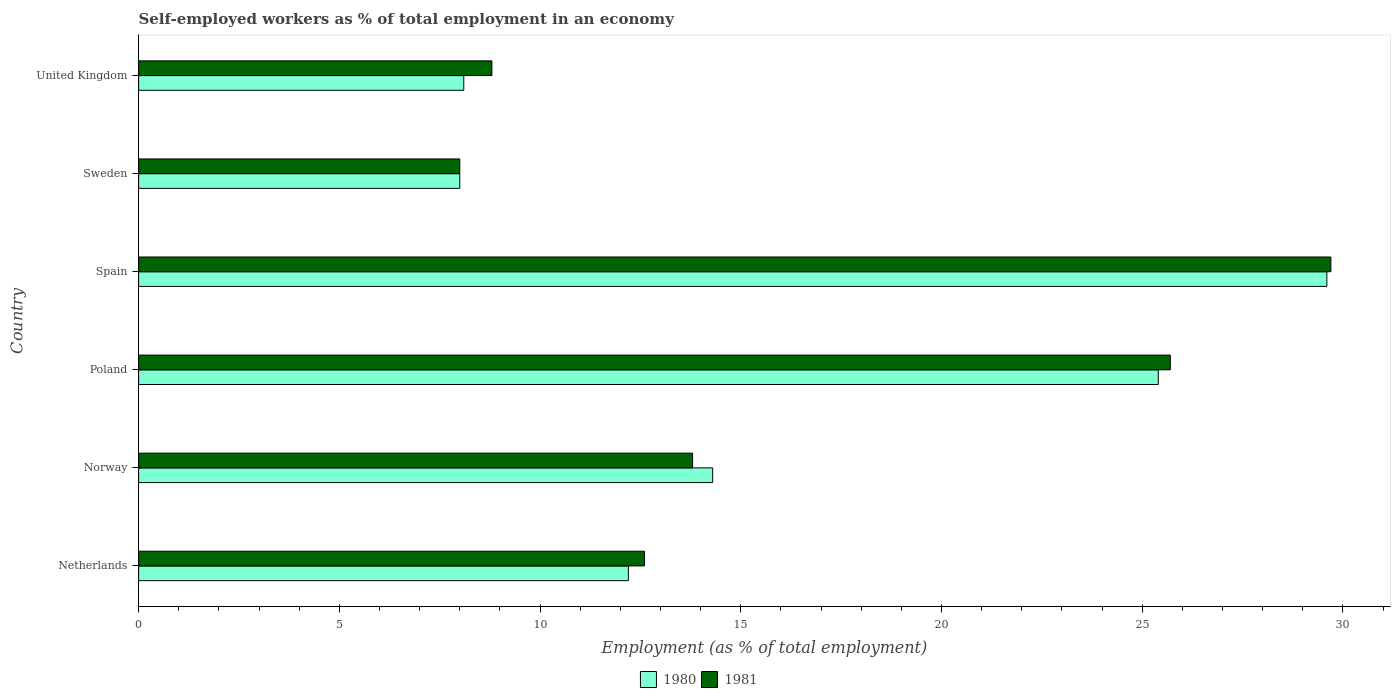How many groups of bars are there?
Your answer should be very brief. 6. What is the label of the 4th group of bars from the top?
Your response must be concise. Poland. What is the percentage of self-employed workers in 1981 in Spain?
Your answer should be compact. 29.7. Across all countries, what is the maximum percentage of self-employed workers in 1980?
Your answer should be compact. 29.6. In which country was the percentage of self-employed workers in 1980 maximum?
Provide a succinct answer. Spain. In which country was the percentage of self-employed workers in 1980 minimum?
Make the answer very short. Sweden. What is the total percentage of self-employed workers in 1981 in the graph?
Offer a very short reply. 98.6. What is the difference between the percentage of self-employed workers in 1981 in Sweden and that in United Kingdom?
Offer a terse response. -0.8. What is the difference between the percentage of self-employed workers in 1980 in Spain and the percentage of self-employed workers in 1981 in United Kingdom?
Your answer should be compact. 20.8. What is the average percentage of self-employed workers in 1980 per country?
Ensure brevity in your answer.  16.27. What is the difference between the percentage of self-employed workers in 1981 and percentage of self-employed workers in 1980 in Norway?
Your answer should be compact. -0.5. In how many countries, is the percentage of self-employed workers in 1981 greater than 12 %?
Your response must be concise. 4. What is the ratio of the percentage of self-employed workers in 1980 in Norway to that in United Kingdom?
Give a very brief answer. 1.77. Is the percentage of self-employed workers in 1981 in Poland less than that in Sweden?
Your answer should be very brief. No. Is the difference between the percentage of self-employed workers in 1981 in Sweden and United Kingdom greater than the difference between the percentage of self-employed workers in 1980 in Sweden and United Kingdom?
Your answer should be very brief. No. What is the difference between the highest and the second highest percentage of self-employed workers in 1981?
Give a very brief answer. 4. What is the difference between the highest and the lowest percentage of self-employed workers in 1981?
Keep it short and to the point. 21.7. In how many countries, is the percentage of self-employed workers in 1980 greater than the average percentage of self-employed workers in 1980 taken over all countries?
Ensure brevity in your answer.  2. Is the sum of the percentage of self-employed workers in 1980 in Netherlands and Spain greater than the maximum percentage of self-employed workers in 1981 across all countries?
Keep it short and to the point. Yes. What does the 2nd bar from the bottom in Sweden represents?
Offer a terse response. 1981. How many countries are there in the graph?
Your answer should be compact. 6. What is the difference between two consecutive major ticks on the X-axis?
Your answer should be very brief. 5. Does the graph contain any zero values?
Give a very brief answer. No. Does the graph contain grids?
Offer a terse response. No. Where does the legend appear in the graph?
Provide a short and direct response. Bottom center. How many legend labels are there?
Offer a very short reply. 2. What is the title of the graph?
Offer a terse response. Self-employed workers as % of total employment in an economy. What is the label or title of the X-axis?
Make the answer very short. Employment (as % of total employment). What is the label or title of the Y-axis?
Ensure brevity in your answer.  Country. What is the Employment (as % of total employment) of 1980 in Netherlands?
Offer a terse response. 12.2. What is the Employment (as % of total employment) of 1981 in Netherlands?
Your response must be concise. 12.6. What is the Employment (as % of total employment) in 1980 in Norway?
Give a very brief answer. 14.3. What is the Employment (as % of total employment) in 1981 in Norway?
Give a very brief answer. 13.8. What is the Employment (as % of total employment) of 1980 in Poland?
Your answer should be very brief. 25.4. What is the Employment (as % of total employment) of 1981 in Poland?
Provide a succinct answer. 25.7. What is the Employment (as % of total employment) of 1980 in Spain?
Ensure brevity in your answer.  29.6. What is the Employment (as % of total employment) in 1981 in Spain?
Provide a succinct answer. 29.7. What is the Employment (as % of total employment) of 1980 in Sweden?
Provide a succinct answer. 8. What is the Employment (as % of total employment) in 1981 in Sweden?
Your response must be concise. 8. What is the Employment (as % of total employment) in 1980 in United Kingdom?
Keep it short and to the point. 8.1. What is the Employment (as % of total employment) of 1981 in United Kingdom?
Your answer should be compact. 8.8. Across all countries, what is the maximum Employment (as % of total employment) of 1980?
Make the answer very short. 29.6. Across all countries, what is the maximum Employment (as % of total employment) of 1981?
Provide a succinct answer. 29.7. Across all countries, what is the minimum Employment (as % of total employment) in 1980?
Your answer should be very brief. 8. What is the total Employment (as % of total employment) of 1980 in the graph?
Make the answer very short. 97.6. What is the total Employment (as % of total employment) of 1981 in the graph?
Offer a terse response. 98.6. What is the difference between the Employment (as % of total employment) of 1980 in Netherlands and that in Norway?
Offer a very short reply. -2.1. What is the difference between the Employment (as % of total employment) in 1981 in Netherlands and that in Norway?
Offer a very short reply. -1.2. What is the difference between the Employment (as % of total employment) of 1981 in Netherlands and that in Poland?
Offer a very short reply. -13.1. What is the difference between the Employment (as % of total employment) of 1980 in Netherlands and that in Spain?
Keep it short and to the point. -17.4. What is the difference between the Employment (as % of total employment) of 1981 in Netherlands and that in Spain?
Give a very brief answer. -17.1. What is the difference between the Employment (as % of total employment) in 1981 in Netherlands and that in Sweden?
Your response must be concise. 4.6. What is the difference between the Employment (as % of total employment) in 1980 in Netherlands and that in United Kingdom?
Provide a succinct answer. 4.1. What is the difference between the Employment (as % of total employment) of 1981 in Norway and that in Poland?
Make the answer very short. -11.9. What is the difference between the Employment (as % of total employment) of 1980 in Norway and that in Spain?
Make the answer very short. -15.3. What is the difference between the Employment (as % of total employment) of 1981 in Norway and that in Spain?
Provide a short and direct response. -15.9. What is the difference between the Employment (as % of total employment) in 1980 in Norway and that in Sweden?
Make the answer very short. 6.3. What is the difference between the Employment (as % of total employment) of 1981 in Norway and that in Sweden?
Give a very brief answer. 5.8. What is the difference between the Employment (as % of total employment) of 1980 in Poland and that in Sweden?
Ensure brevity in your answer.  17.4. What is the difference between the Employment (as % of total employment) of 1981 in Poland and that in Sweden?
Ensure brevity in your answer.  17.7. What is the difference between the Employment (as % of total employment) of 1980 in Poland and that in United Kingdom?
Offer a terse response. 17.3. What is the difference between the Employment (as % of total employment) of 1980 in Spain and that in Sweden?
Your answer should be very brief. 21.6. What is the difference between the Employment (as % of total employment) of 1981 in Spain and that in Sweden?
Give a very brief answer. 21.7. What is the difference between the Employment (as % of total employment) in 1980 in Spain and that in United Kingdom?
Provide a short and direct response. 21.5. What is the difference between the Employment (as % of total employment) of 1981 in Spain and that in United Kingdom?
Your answer should be very brief. 20.9. What is the difference between the Employment (as % of total employment) of 1980 in Sweden and that in United Kingdom?
Offer a very short reply. -0.1. What is the difference between the Employment (as % of total employment) in 1981 in Sweden and that in United Kingdom?
Keep it short and to the point. -0.8. What is the difference between the Employment (as % of total employment) in 1980 in Netherlands and the Employment (as % of total employment) in 1981 in Norway?
Provide a succinct answer. -1.6. What is the difference between the Employment (as % of total employment) of 1980 in Netherlands and the Employment (as % of total employment) of 1981 in Spain?
Your answer should be very brief. -17.5. What is the difference between the Employment (as % of total employment) in 1980 in Norway and the Employment (as % of total employment) in 1981 in Poland?
Provide a short and direct response. -11.4. What is the difference between the Employment (as % of total employment) in 1980 in Norway and the Employment (as % of total employment) in 1981 in Spain?
Offer a terse response. -15.4. What is the difference between the Employment (as % of total employment) of 1980 in Norway and the Employment (as % of total employment) of 1981 in United Kingdom?
Your answer should be very brief. 5.5. What is the difference between the Employment (as % of total employment) of 1980 in Poland and the Employment (as % of total employment) of 1981 in Spain?
Ensure brevity in your answer.  -4.3. What is the difference between the Employment (as % of total employment) in 1980 in Spain and the Employment (as % of total employment) in 1981 in Sweden?
Give a very brief answer. 21.6. What is the difference between the Employment (as % of total employment) in 1980 in Spain and the Employment (as % of total employment) in 1981 in United Kingdom?
Your answer should be compact. 20.8. What is the average Employment (as % of total employment) in 1980 per country?
Offer a terse response. 16.27. What is the average Employment (as % of total employment) of 1981 per country?
Your response must be concise. 16.43. What is the difference between the Employment (as % of total employment) in 1980 and Employment (as % of total employment) in 1981 in Netherlands?
Keep it short and to the point. -0.4. What is the difference between the Employment (as % of total employment) of 1980 and Employment (as % of total employment) of 1981 in Spain?
Your answer should be compact. -0.1. What is the difference between the Employment (as % of total employment) in 1980 and Employment (as % of total employment) in 1981 in Sweden?
Give a very brief answer. 0. What is the ratio of the Employment (as % of total employment) in 1980 in Netherlands to that in Norway?
Keep it short and to the point. 0.85. What is the ratio of the Employment (as % of total employment) in 1981 in Netherlands to that in Norway?
Make the answer very short. 0.91. What is the ratio of the Employment (as % of total employment) in 1980 in Netherlands to that in Poland?
Provide a succinct answer. 0.48. What is the ratio of the Employment (as % of total employment) of 1981 in Netherlands to that in Poland?
Offer a very short reply. 0.49. What is the ratio of the Employment (as % of total employment) in 1980 in Netherlands to that in Spain?
Keep it short and to the point. 0.41. What is the ratio of the Employment (as % of total employment) of 1981 in Netherlands to that in Spain?
Provide a short and direct response. 0.42. What is the ratio of the Employment (as % of total employment) of 1980 in Netherlands to that in Sweden?
Your response must be concise. 1.52. What is the ratio of the Employment (as % of total employment) in 1981 in Netherlands to that in Sweden?
Keep it short and to the point. 1.57. What is the ratio of the Employment (as % of total employment) in 1980 in Netherlands to that in United Kingdom?
Offer a terse response. 1.51. What is the ratio of the Employment (as % of total employment) of 1981 in Netherlands to that in United Kingdom?
Keep it short and to the point. 1.43. What is the ratio of the Employment (as % of total employment) of 1980 in Norway to that in Poland?
Provide a short and direct response. 0.56. What is the ratio of the Employment (as % of total employment) in 1981 in Norway to that in Poland?
Your response must be concise. 0.54. What is the ratio of the Employment (as % of total employment) in 1980 in Norway to that in Spain?
Provide a succinct answer. 0.48. What is the ratio of the Employment (as % of total employment) in 1981 in Norway to that in Spain?
Offer a terse response. 0.46. What is the ratio of the Employment (as % of total employment) in 1980 in Norway to that in Sweden?
Offer a very short reply. 1.79. What is the ratio of the Employment (as % of total employment) in 1981 in Norway to that in Sweden?
Ensure brevity in your answer.  1.73. What is the ratio of the Employment (as % of total employment) in 1980 in Norway to that in United Kingdom?
Ensure brevity in your answer.  1.77. What is the ratio of the Employment (as % of total employment) of 1981 in Norway to that in United Kingdom?
Your answer should be compact. 1.57. What is the ratio of the Employment (as % of total employment) of 1980 in Poland to that in Spain?
Ensure brevity in your answer.  0.86. What is the ratio of the Employment (as % of total employment) of 1981 in Poland to that in Spain?
Give a very brief answer. 0.87. What is the ratio of the Employment (as % of total employment) of 1980 in Poland to that in Sweden?
Provide a succinct answer. 3.17. What is the ratio of the Employment (as % of total employment) in 1981 in Poland to that in Sweden?
Offer a very short reply. 3.21. What is the ratio of the Employment (as % of total employment) of 1980 in Poland to that in United Kingdom?
Your answer should be very brief. 3.14. What is the ratio of the Employment (as % of total employment) in 1981 in Poland to that in United Kingdom?
Provide a short and direct response. 2.92. What is the ratio of the Employment (as % of total employment) in 1981 in Spain to that in Sweden?
Your answer should be very brief. 3.71. What is the ratio of the Employment (as % of total employment) in 1980 in Spain to that in United Kingdom?
Your response must be concise. 3.65. What is the ratio of the Employment (as % of total employment) of 1981 in Spain to that in United Kingdom?
Your answer should be compact. 3.38. What is the difference between the highest and the second highest Employment (as % of total employment) in 1980?
Provide a short and direct response. 4.2. What is the difference between the highest and the lowest Employment (as % of total employment) in 1980?
Provide a succinct answer. 21.6. What is the difference between the highest and the lowest Employment (as % of total employment) of 1981?
Provide a short and direct response. 21.7. 